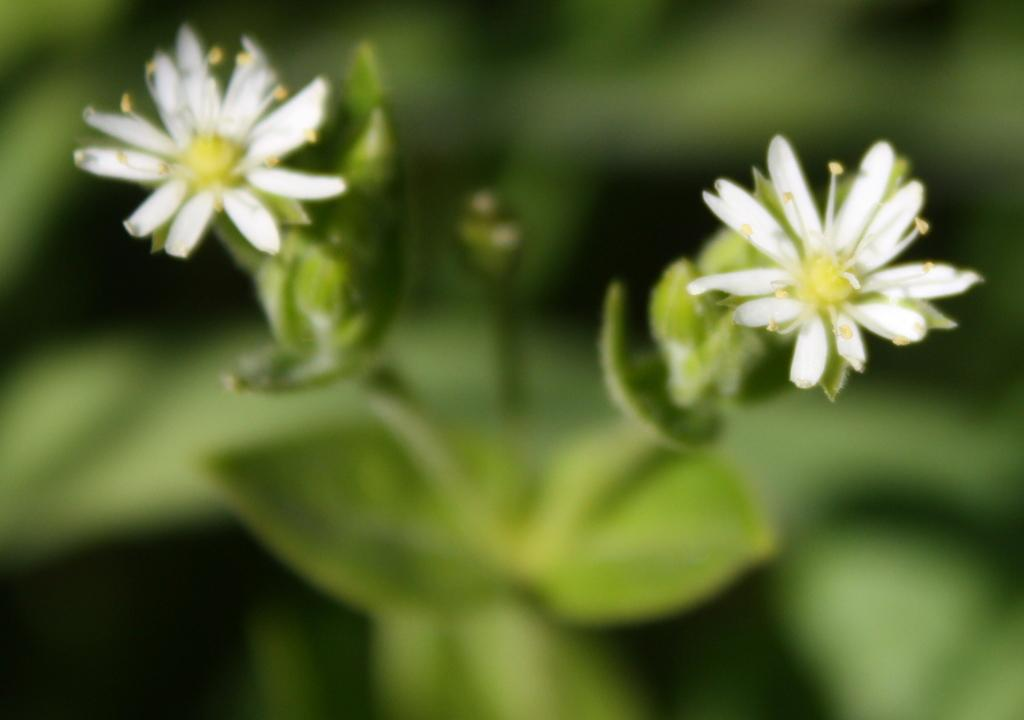What type of plant can be seen in the image? There is a plant with flowers in the image. Can you describe the background of the image? The background of the image is blurred. What type of nose can be seen on the plant in the image? There is no nose present on the plant in the image, as plants do not have noses. Is there a railway visible in the image? There is no railway present in the image. 